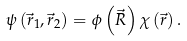Convert formula to latex. <formula><loc_0><loc_0><loc_500><loc_500>\psi \left ( \vec { r } _ { 1 } , \vec { r } _ { 2 } \right ) = \phi \left ( \vec { R } \right ) \chi \left ( \vec { r } \right ) .</formula> 